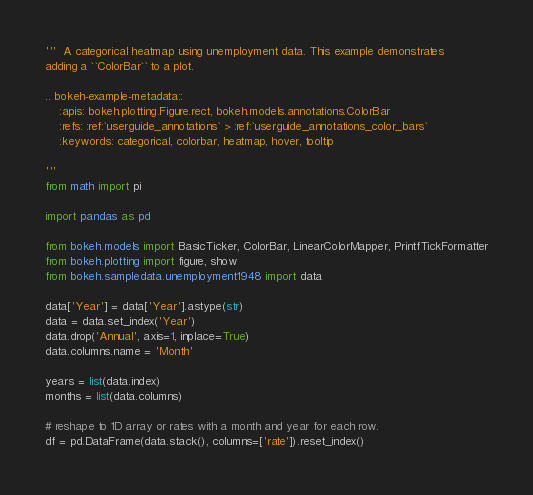<code> <loc_0><loc_0><loc_500><loc_500><_Python_>'''  A categorical heatmap using unemployment data. This example demonstrates
adding a ``ColorBar`` to a plot.

.. bokeh-example-metadata::
    :apis: bokeh.plotting.Figure.rect, bokeh.models.annotations.ColorBar
    :refs: :ref:`userguide_annotations` > :ref:`userguide_annotations_color_bars`
    :keywords: categorical, colorbar, heatmap, hover, tooltip

'''
from math import pi

import pandas as pd

from bokeh.models import BasicTicker, ColorBar, LinearColorMapper, PrintfTickFormatter
from bokeh.plotting import figure, show
from bokeh.sampledata.unemployment1948 import data

data['Year'] = data['Year'].astype(str)
data = data.set_index('Year')
data.drop('Annual', axis=1, inplace=True)
data.columns.name = 'Month'

years = list(data.index)
months = list(data.columns)

# reshape to 1D array or rates with a month and year for each row.
df = pd.DataFrame(data.stack(), columns=['rate']).reset_index()
</code> 